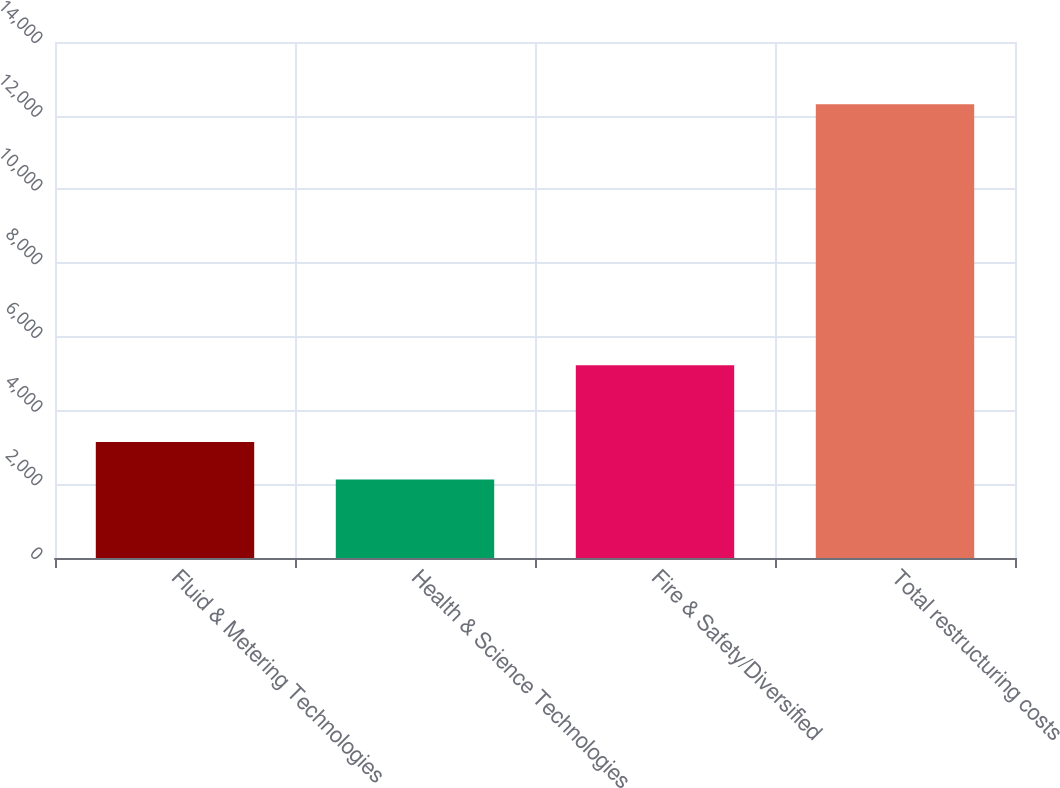Convert chart to OTSL. <chart><loc_0><loc_0><loc_500><loc_500><bar_chart><fcel>Fluid & Metering Technologies<fcel>Health & Science Technologies<fcel>Fire & Safety/Diversified<fcel>Total restructuring costs<nl><fcel>3148.4<fcel>2130<fcel>5227<fcel>12314<nl></chart> 